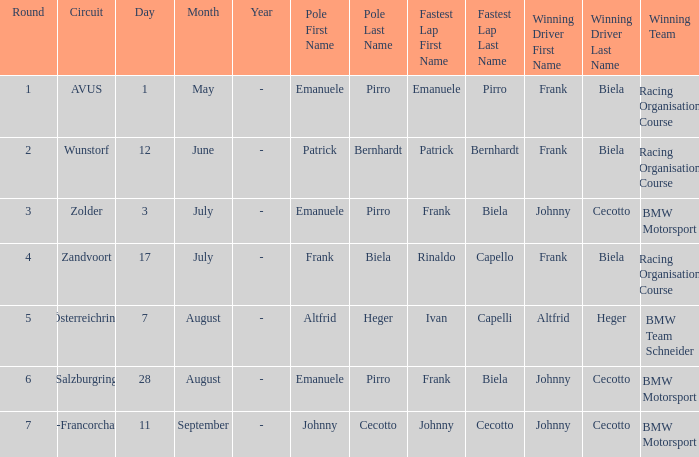Who had pole position in round 7? Johnny Cecotto. 